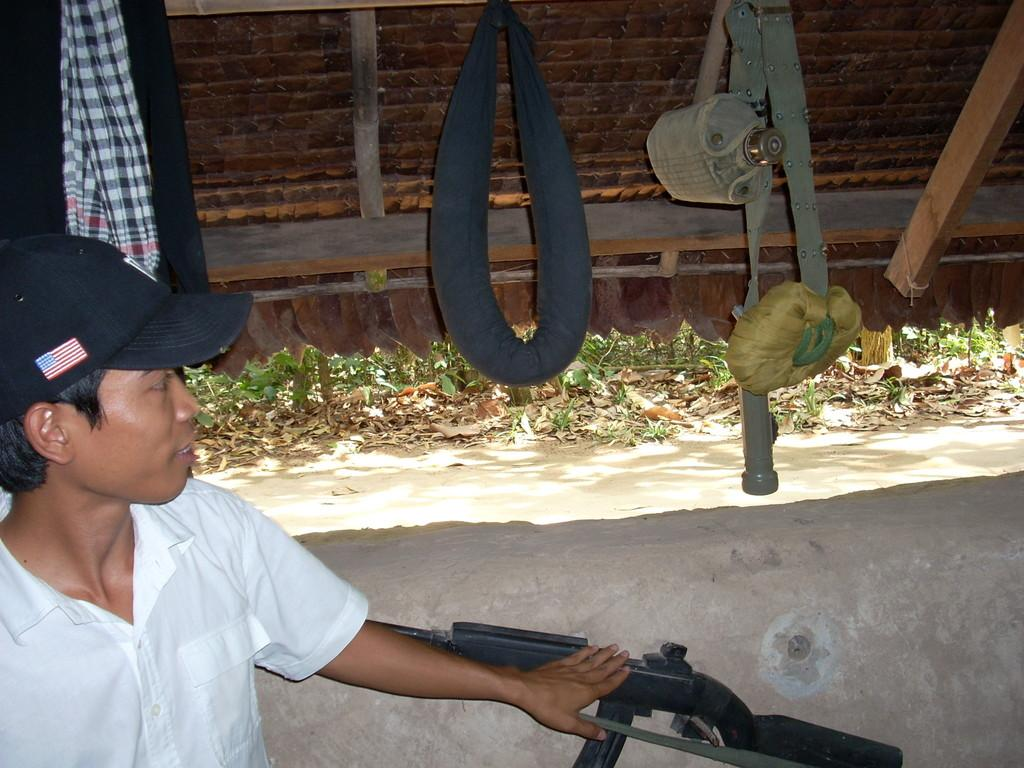Who is the main subject in the image? There is a boy in the image. Where is the boy located in the image? The boy is on the left side of the image. What object can be seen at the bottom side of the image? There is a gun at the bottom side of the image. What is present in the top left side of the image? There are clothes in the top left side of the image. How many pears are on the ground in the image? There are no pears present in the image. Do the boy and his brothers appear in the image? The provided facts do not mention any brothers, so we cannot determine if they are present in the image. 